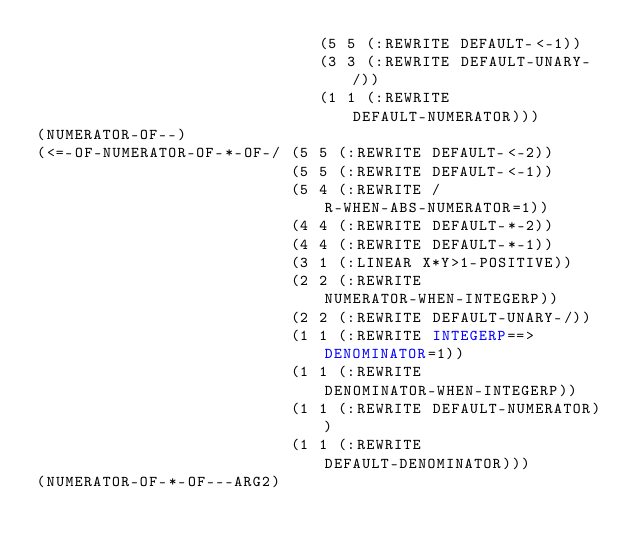<code> <loc_0><loc_0><loc_500><loc_500><_Lisp_>                              (5 5 (:REWRITE DEFAULT-<-1))
                              (3 3 (:REWRITE DEFAULT-UNARY-/))
                              (1 1 (:REWRITE DEFAULT-NUMERATOR)))
(NUMERATOR-OF--)
(<=-OF-NUMERATOR-OF-*-OF-/ (5 5 (:REWRITE DEFAULT-<-2))
                           (5 5 (:REWRITE DEFAULT-<-1))
                           (5 4 (:REWRITE /R-WHEN-ABS-NUMERATOR=1))
                           (4 4 (:REWRITE DEFAULT-*-2))
                           (4 4 (:REWRITE DEFAULT-*-1))
                           (3 1 (:LINEAR X*Y>1-POSITIVE))
                           (2 2 (:REWRITE NUMERATOR-WHEN-INTEGERP))
                           (2 2 (:REWRITE DEFAULT-UNARY-/))
                           (1 1 (:REWRITE INTEGERP==>DENOMINATOR=1))
                           (1 1 (:REWRITE DENOMINATOR-WHEN-INTEGERP))
                           (1 1 (:REWRITE DEFAULT-NUMERATOR))
                           (1 1 (:REWRITE DEFAULT-DENOMINATOR)))
(NUMERATOR-OF-*-OF---ARG2)
</code> 